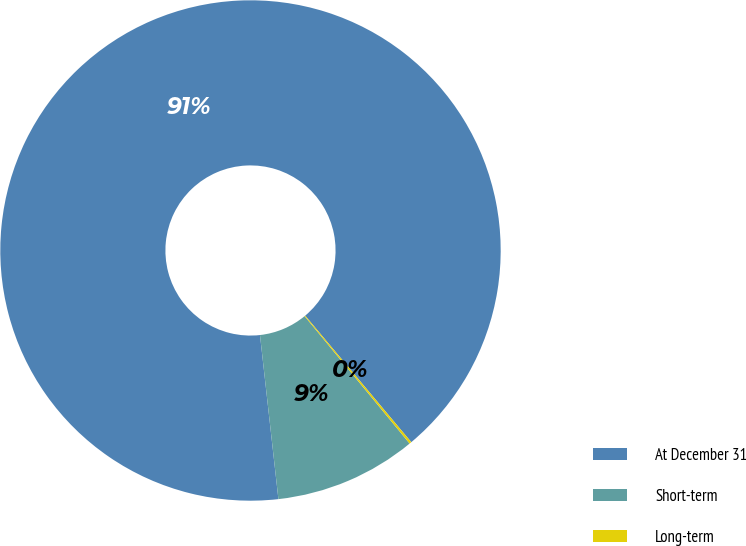<chart> <loc_0><loc_0><loc_500><loc_500><pie_chart><fcel>At December 31<fcel>Short-term<fcel>Long-term<nl><fcel>90.66%<fcel>9.19%<fcel>0.14%<nl></chart> 